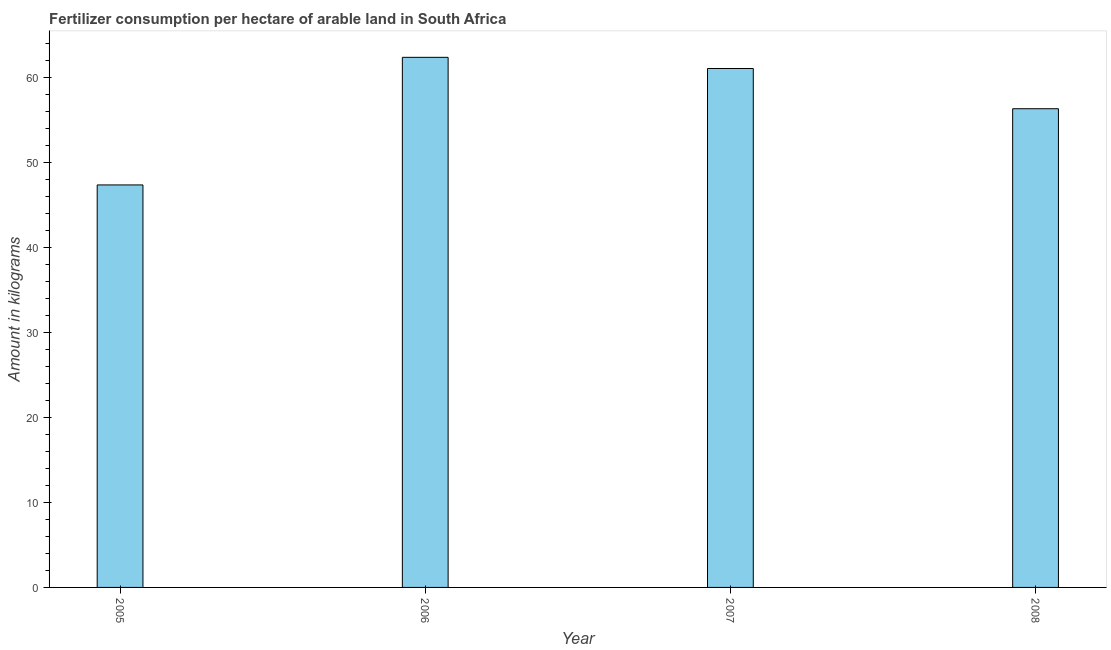Does the graph contain any zero values?
Provide a short and direct response. No. Does the graph contain grids?
Provide a short and direct response. No. What is the title of the graph?
Offer a terse response. Fertilizer consumption per hectare of arable land in South Africa . What is the label or title of the X-axis?
Offer a very short reply. Year. What is the label or title of the Y-axis?
Provide a succinct answer. Amount in kilograms. What is the amount of fertilizer consumption in 2005?
Give a very brief answer. 47.33. Across all years, what is the maximum amount of fertilizer consumption?
Make the answer very short. 62.34. Across all years, what is the minimum amount of fertilizer consumption?
Give a very brief answer. 47.33. What is the sum of the amount of fertilizer consumption?
Your response must be concise. 226.98. What is the difference between the amount of fertilizer consumption in 2007 and 2008?
Offer a very short reply. 4.73. What is the average amount of fertilizer consumption per year?
Give a very brief answer. 56.75. What is the median amount of fertilizer consumption?
Offer a terse response. 58.66. What is the ratio of the amount of fertilizer consumption in 2005 to that in 2008?
Give a very brief answer. 0.84. What is the difference between the highest and the second highest amount of fertilizer consumption?
Your response must be concise. 1.31. What is the difference between the highest and the lowest amount of fertilizer consumption?
Make the answer very short. 15.01. Are the values on the major ticks of Y-axis written in scientific E-notation?
Offer a very short reply. No. What is the Amount in kilograms in 2005?
Give a very brief answer. 47.33. What is the Amount in kilograms in 2006?
Your answer should be very brief. 62.34. What is the Amount in kilograms of 2007?
Provide a short and direct response. 61.02. What is the Amount in kilograms in 2008?
Your response must be concise. 56.29. What is the difference between the Amount in kilograms in 2005 and 2006?
Your answer should be very brief. -15.01. What is the difference between the Amount in kilograms in 2005 and 2007?
Your response must be concise. -13.69. What is the difference between the Amount in kilograms in 2005 and 2008?
Your answer should be compact. -8.96. What is the difference between the Amount in kilograms in 2006 and 2007?
Make the answer very short. 1.31. What is the difference between the Amount in kilograms in 2006 and 2008?
Keep it short and to the point. 6.04. What is the difference between the Amount in kilograms in 2007 and 2008?
Provide a short and direct response. 4.73. What is the ratio of the Amount in kilograms in 2005 to that in 2006?
Offer a very short reply. 0.76. What is the ratio of the Amount in kilograms in 2005 to that in 2007?
Provide a short and direct response. 0.78. What is the ratio of the Amount in kilograms in 2005 to that in 2008?
Your answer should be very brief. 0.84. What is the ratio of the Amount in kilograms in 2006 to that in 2007?
Keep it short and to the point. 1.02. What is the ratio of the Amount in kilograms in 2006 to that in 2008?
Ensure brevity in your answer.  1.11. What is the ratio of the Amount in kilograms in 2007 to that in 2008?
Your answer should be very brief. 1.08. 